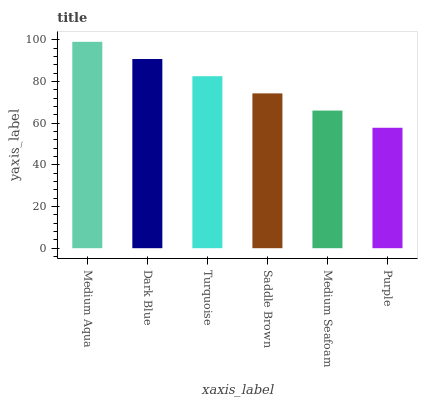Is Purple the minimum?
Answer yes or no. Yes. Is Medium Aqua the maximum?
Answer yes or no. Yes. Is Dark Blue the minimum?
Answer yes or no. No. Is Dark Blue the maximum?
Answer yes or no. No. Is Medium Aqua greater than Dark Blue?
Answer yes or no. Yes. Is Dark Blue less than Medium Aqua?
Answer yes or no. Yes. Is Dark Blue greater than Medium Aqua?
Answer yes or no. No. Is Medium Aqua less than Dark Blue?
Answer yes or no. No. Is Turquoise the high median?
Answer yes or no. Yes. Is Saddle Brown the low median?
Answer yes or no. Yes. Is Medium Aqua the high median?
Answer yes or no. No. Is Medium Seafoam the low median?
Answer yes or no. No. 